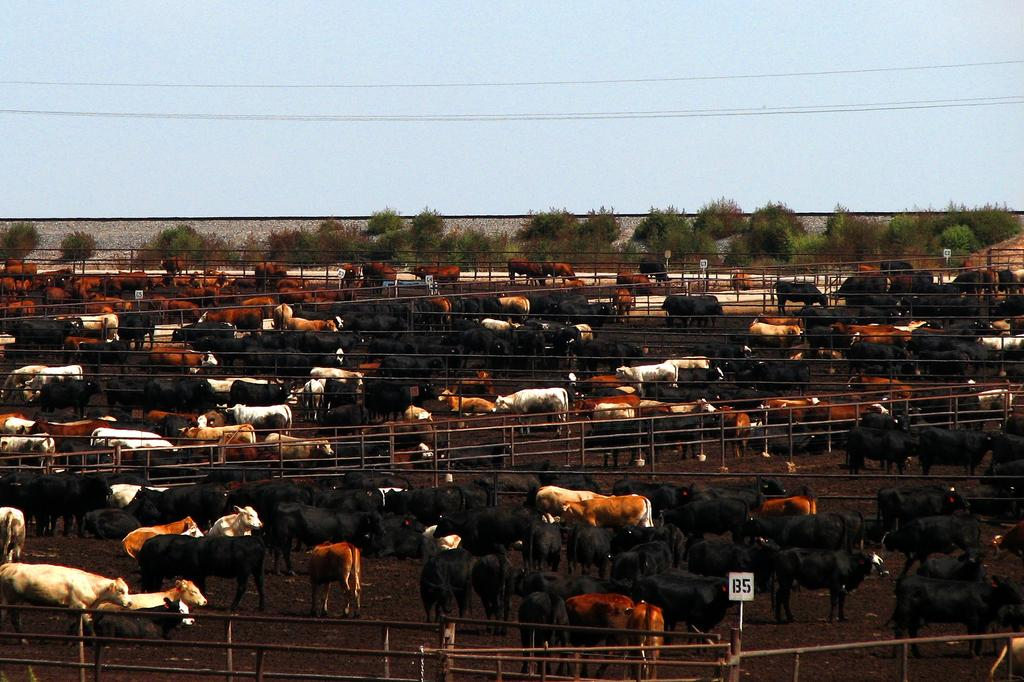What type of living organisms can be seen in the image? There are animals in the image. Where are the animals located? The animals are in a fence. What can be seen in the background of the image? There are trees, wires, and the sky visible in the background of the image. What type of nut is being stored in the basket in the image? There is no basket or nut present in the image. Are the animals in the image attacking each other? There is no indication in the image that the animals are attacking each other. 